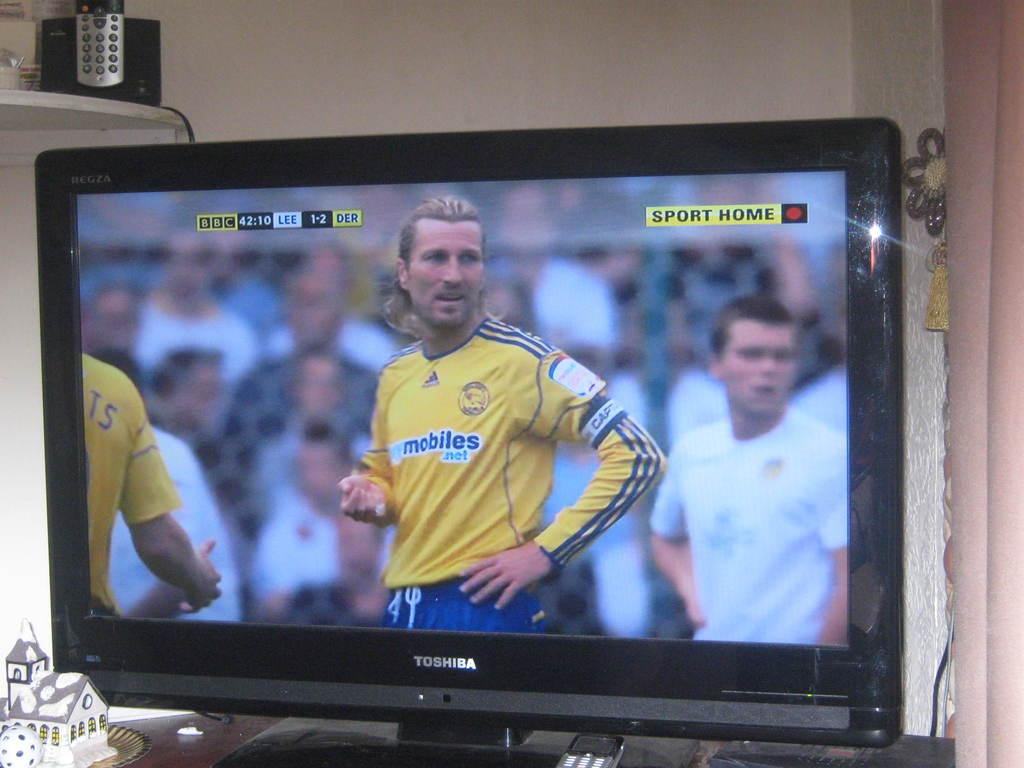<image>
Write a terse but informative summary of the picture. A flat screen is showing a sports game and a player's uniform says mobiles. 